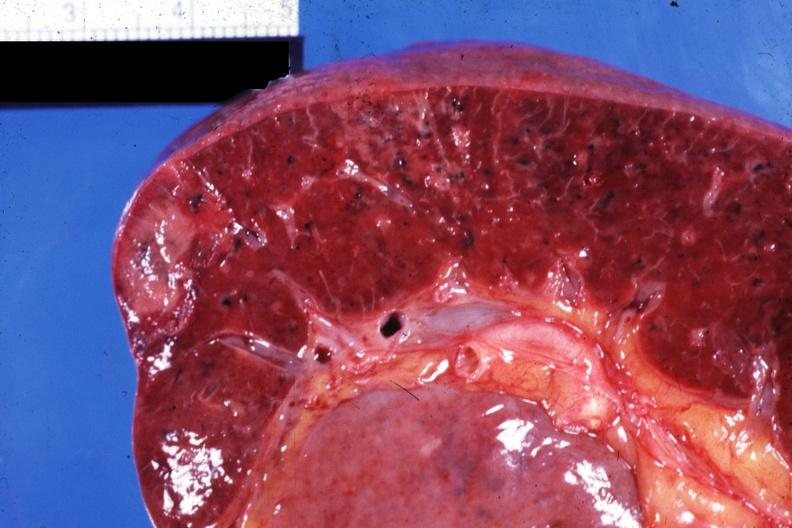what is present?
Answer the question using a single word or phrase. Spleen 